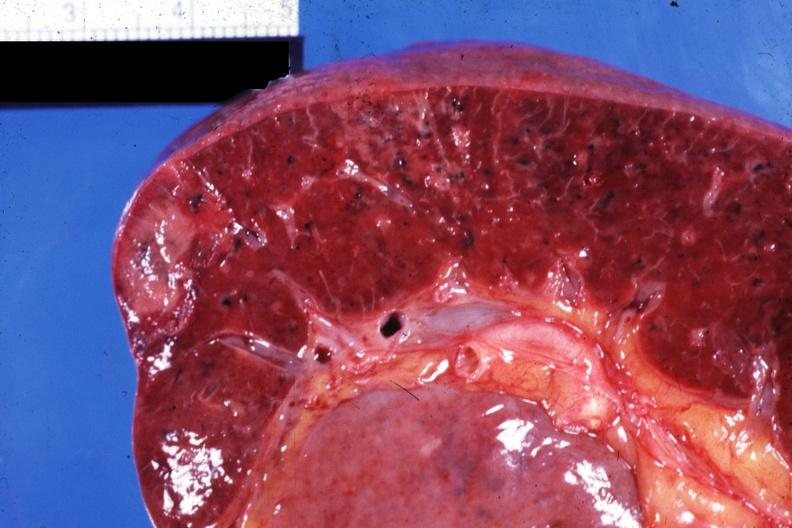what is present?
Answer the question using a single word or phrase. Spleen 